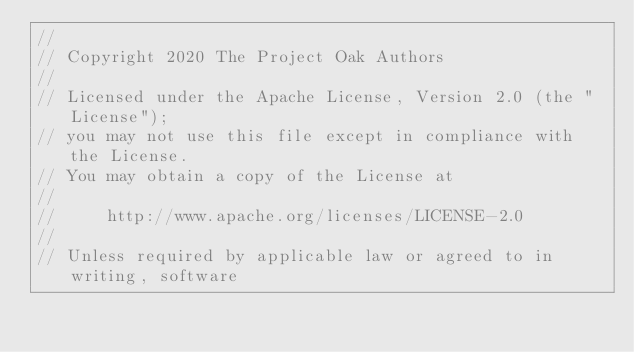<code> <loc_0><loc_0><loc_500><loc_500><_Rust_>//
// Copyright 2020 The Project Oak Authors
//
// Licensed under the Apache License, Version 2.0 (the "License");
// you may not use this file except in compliance with the License.
// You may obtain a copy of the License at
//
//     http://www.apache.org/licenses/LICENSE-2.0
//
// Unless required by applicable law or agreed to in writing, software</code> 